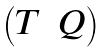Convert formula to latex. <formula><loc_0><loc_0><loc_500><loc_500>\begin{pmatrix} T & Q \end{pmatrix}</formula> 